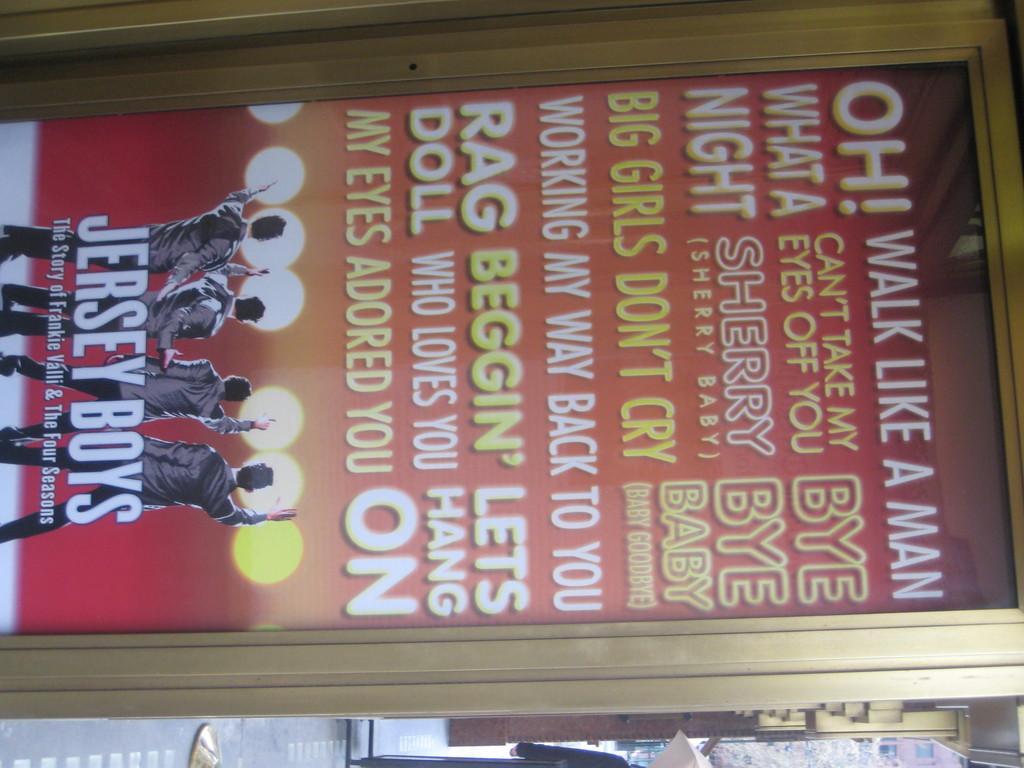Describe this image in one or two sentences. This is a picture of a poster with some words and four people on it , and at the background there is a tree and a building. 